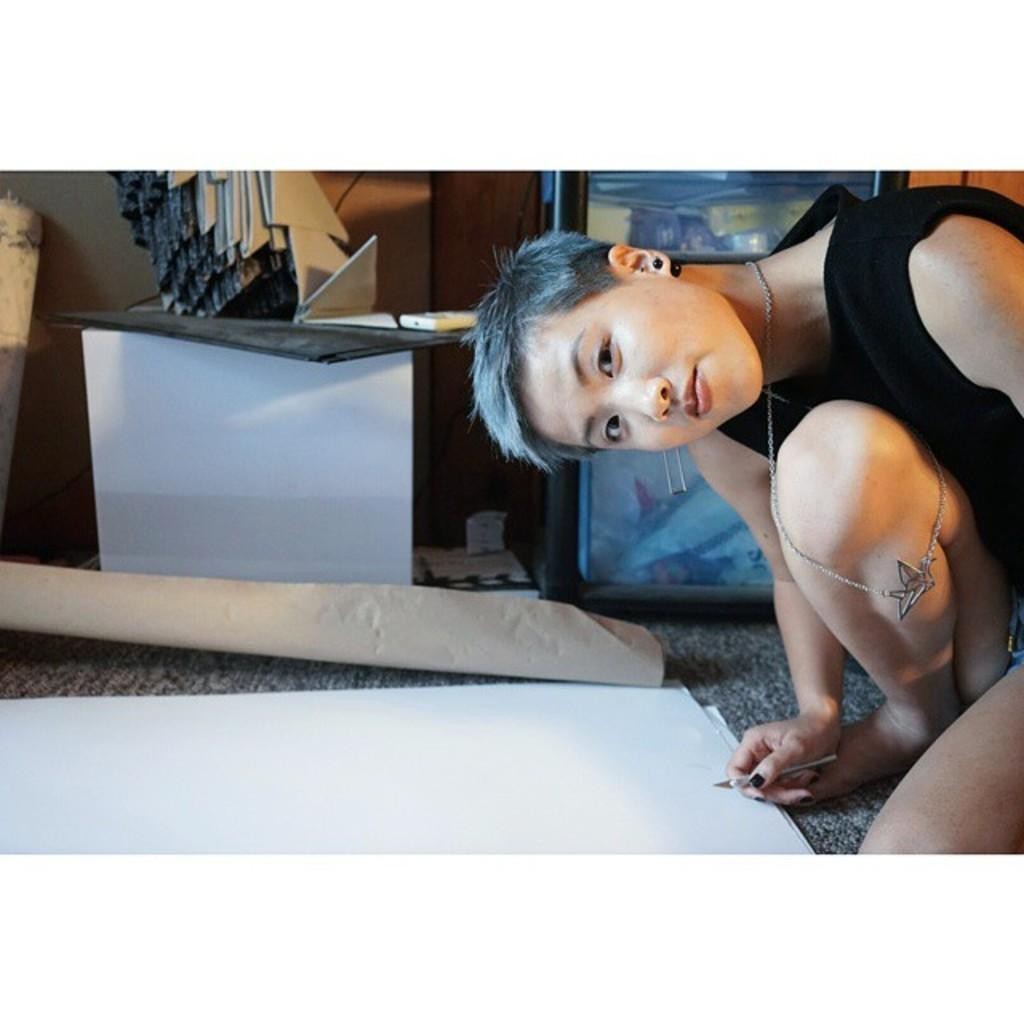What is the main subject of the image? There is a person in the image. What is the person holding in the image? The person is holding a palette knife or a paint brush. What else can be seen in the image besides the person? There are papers and other objects visible in the image. What type of joke is the person telling in the image? There is no indication in the image that the person is telling a joke, so it cannot be determined from the picture. 